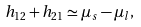<formula> <loc_0><loc_0><loc_500><loc_500>h _ { 1 2 } + h _ { 2 1 } \simeq { \mu } _ { s } - { \mu } _ { l } ,</formula> 